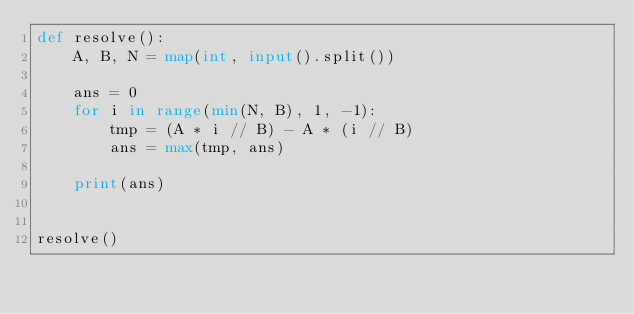Convert code to text. <code><loc_0><loc_0><loc_500><loc_500><_Python_>def resolve():
    A, B, N = map(int, input().split())

    ans = 0
    for i in range(min(N, B), 1, -1):
        tmp = (A * i // B) - A * (i // B)
        ans = max(tmp, ans)

    print(ans)


resolve()</code> 